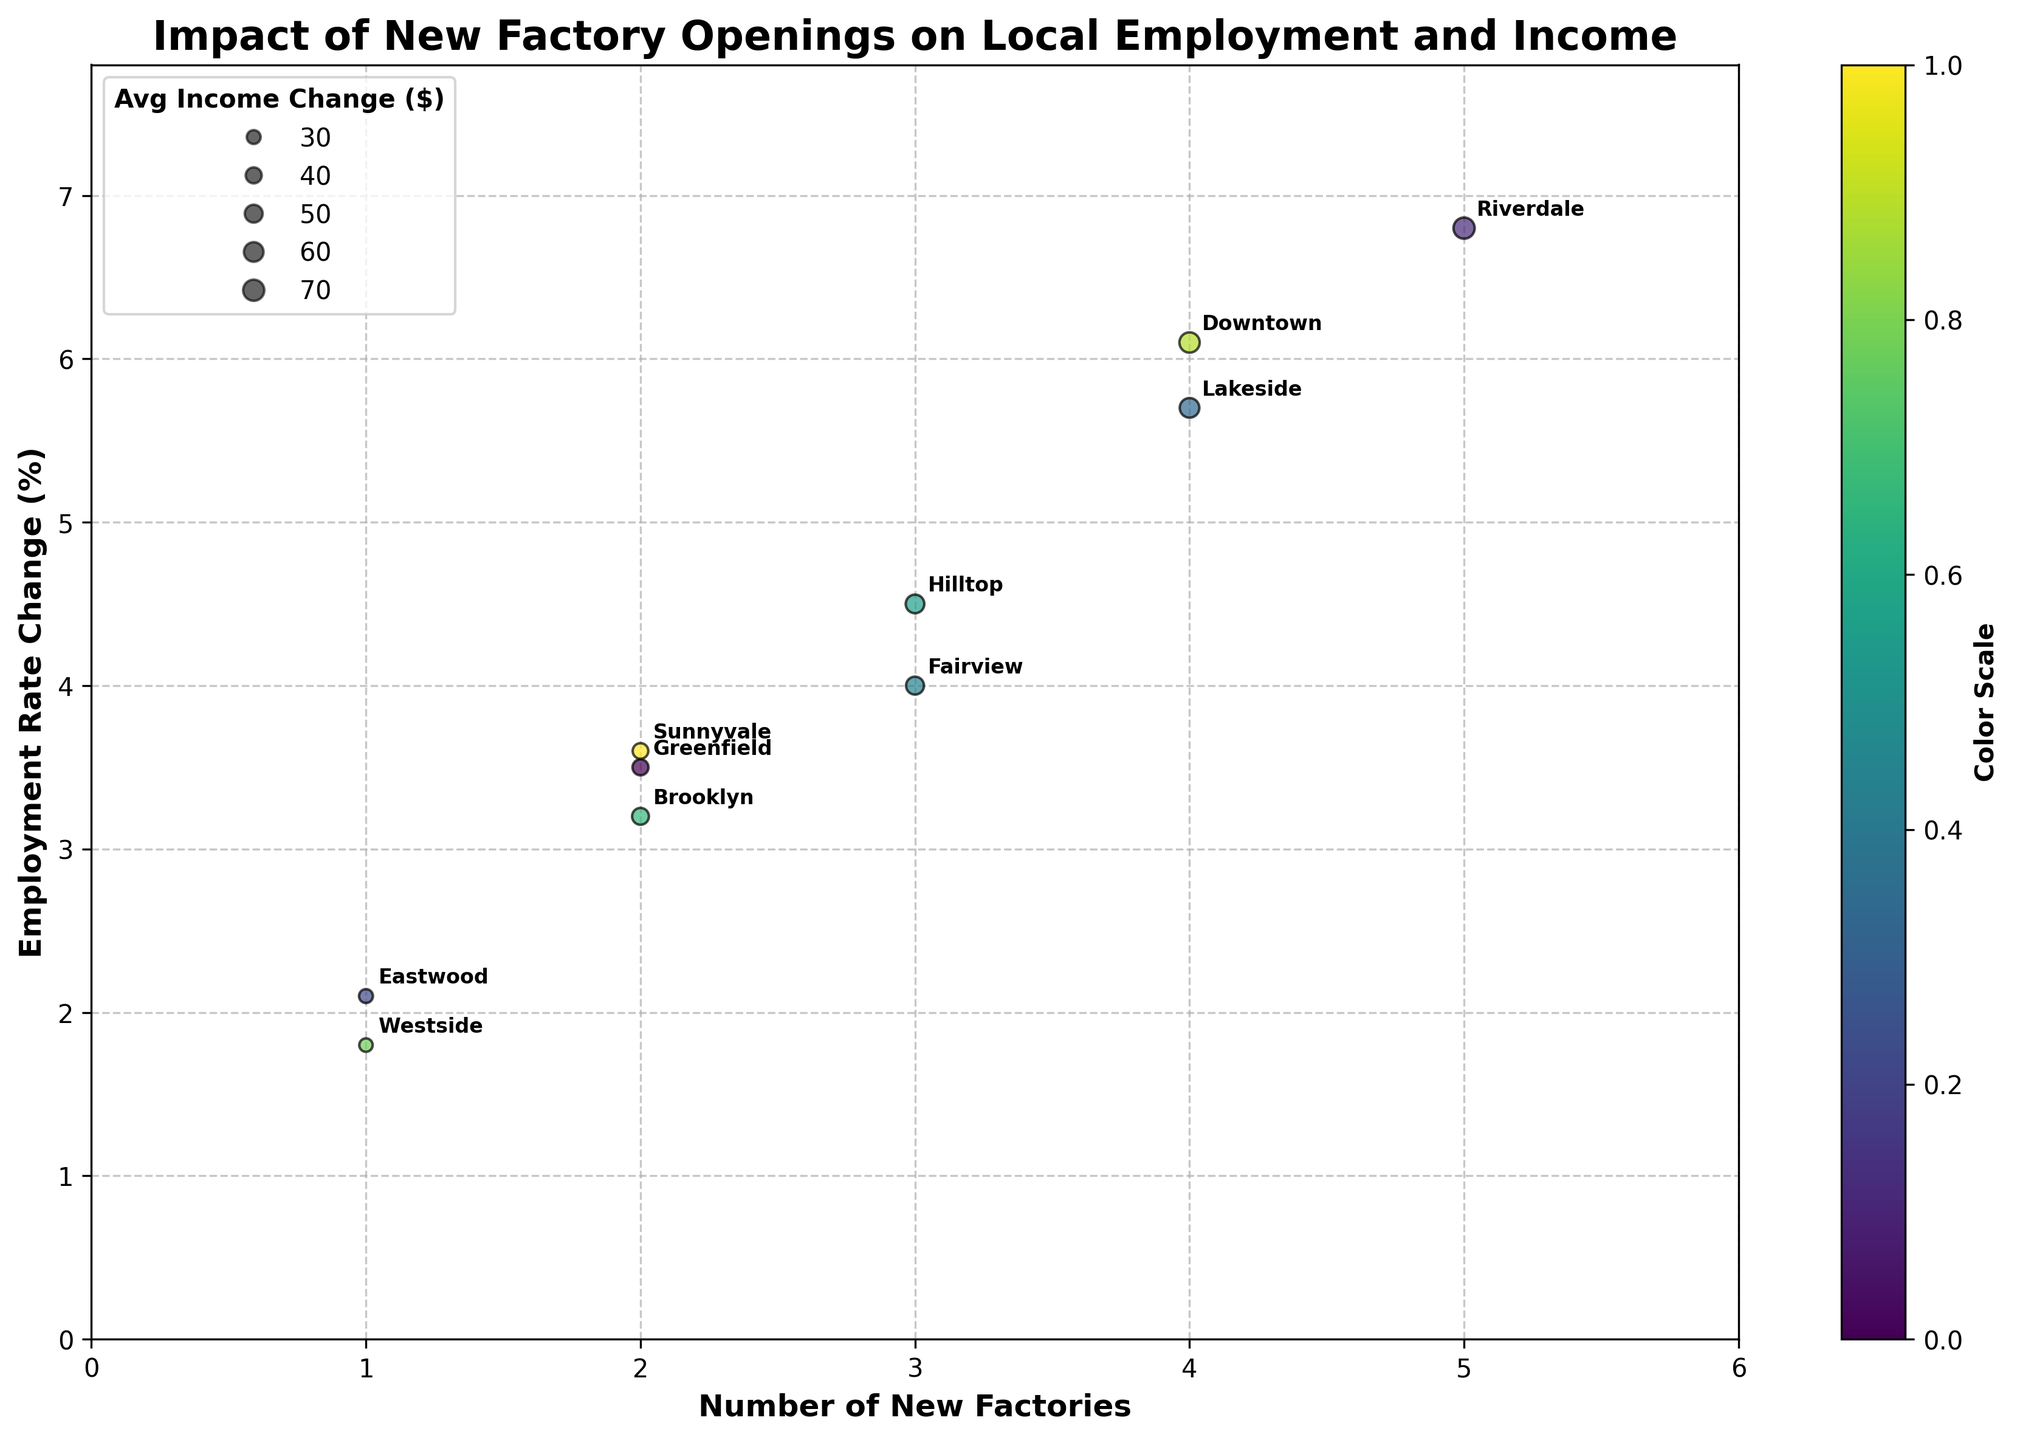How many neighborhoods are represented in the chart? Count the number of unique labels annotated on the chart.
Answer: 10 What is the title of the chart? Look for the text at the top of the chart.
Answer: Impact of New Factory Openings on Local Employment and Income Which neighborhood has the highest employment rate change? Identify the point that has the highest y-coordinate value and check its label.
Answer: Riverdale Which neighborhood has the smallest average income change? Identify the smallest bubble and check its label.
Answer: Westside Which neighborhood has the most number of new factories? Find the highest x-coordinate value and check its label.
Answer: Riverdale How does the employment rate change in Lakeside compare to Downtown? Compare the y-coordinates of Lakeside and Downtown.
Answer: Lakeside is lower What is the employment rate change in neighborhoods with exactly 3 new factories? Find the y-coordinates for the points where x = 3.
Answer: 4.0, 4.5 Are there more neighborhoods with an employment rate change above 5% or below 5%? Count the number of points with y > 5 and compare it with the number of points with y ≤ 5.
Answer: More above 5% How does the color gradient on the chart help interpret the data? Determine that the color gradient represents a scale and adds depth to visual interpretation, making differences in data more apparent.
Answer: Provides visual differentiation 